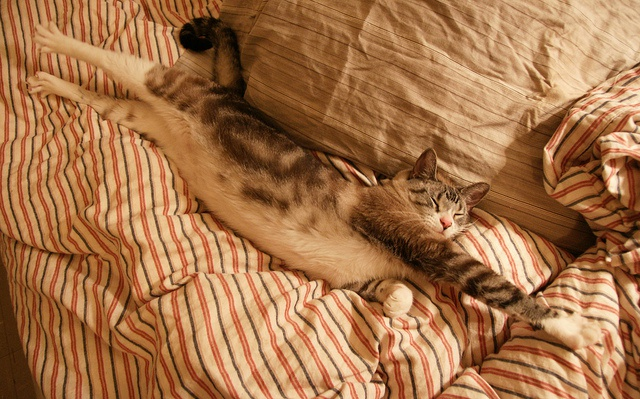Describe the objects in this image and their specific colors. I can see couch in maroon, brown, and tan tones and cat in maroon, brown, and tan tones in this image. 